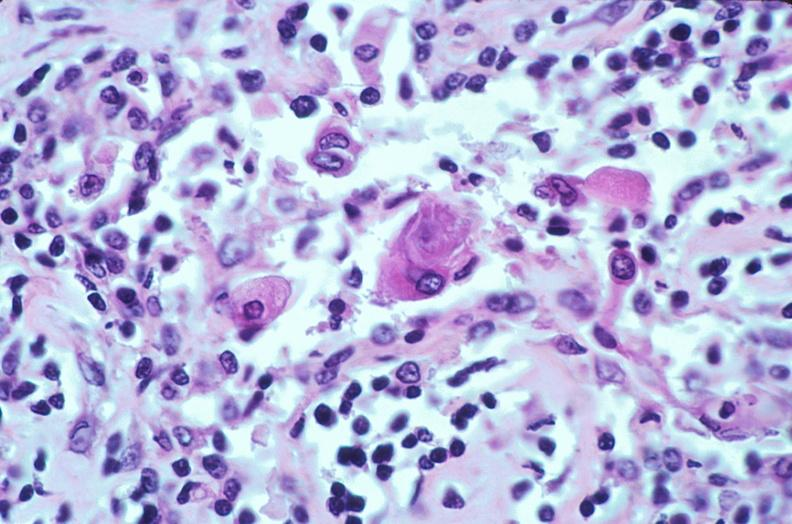does this image show lymph nodes, nodular sclerosing hodgkins disease?
Answer the question using a single word or phrase. Yes 